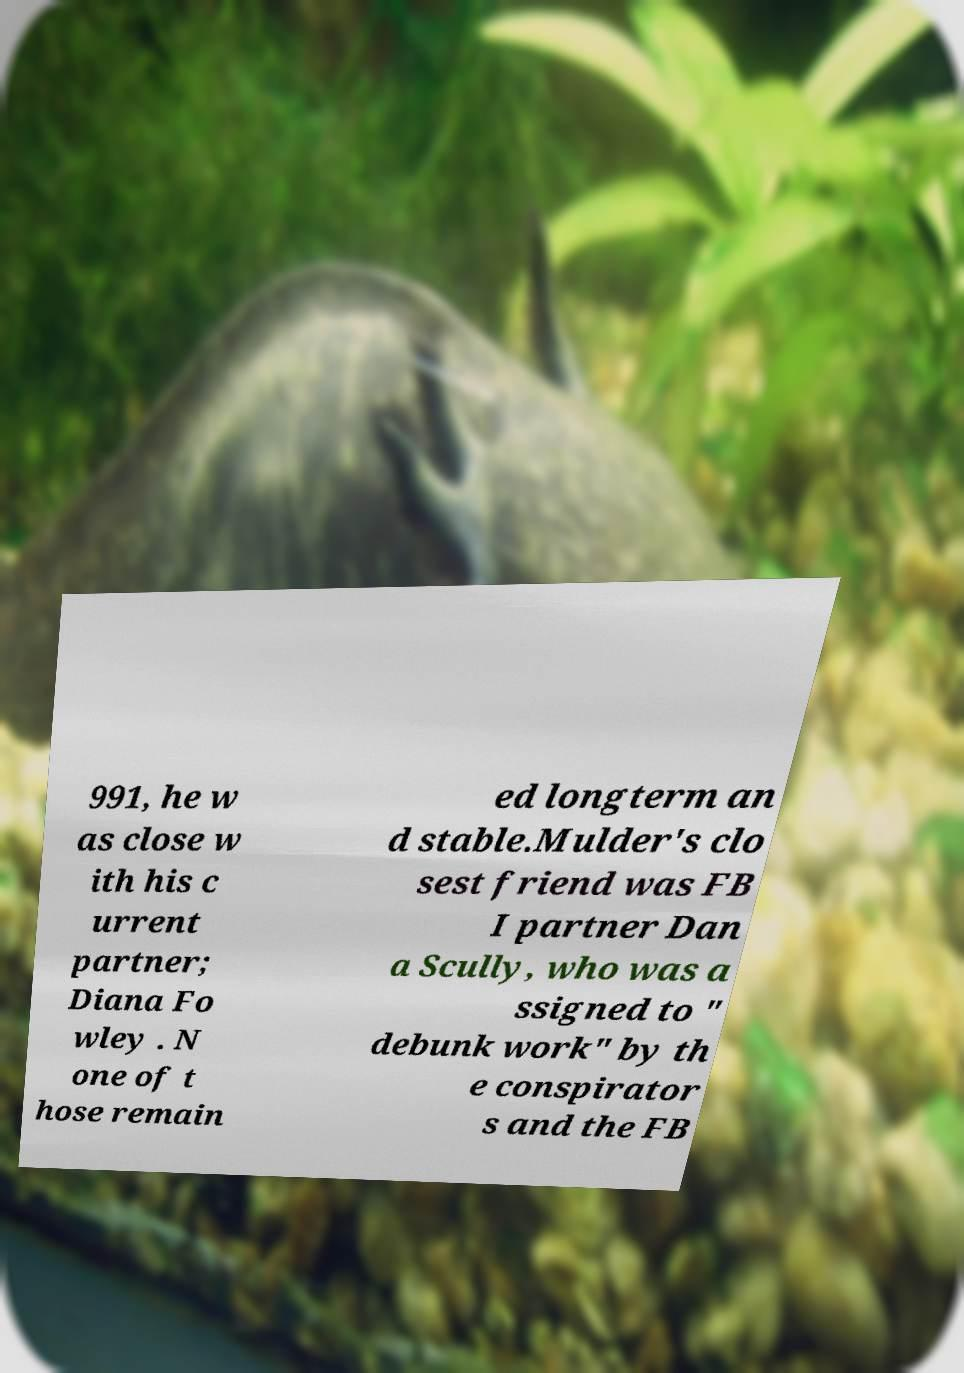Could you extract and type out the text from this image? 991, he w as close w ith his c urrent partner; Diana Fo wley . N one of t hose remain ed longterm an d stable.Mulder's clo sest friend was FB I partner Dan a Scully, who was a ssigned to " debunk work" by th e conspirator s and the FB 